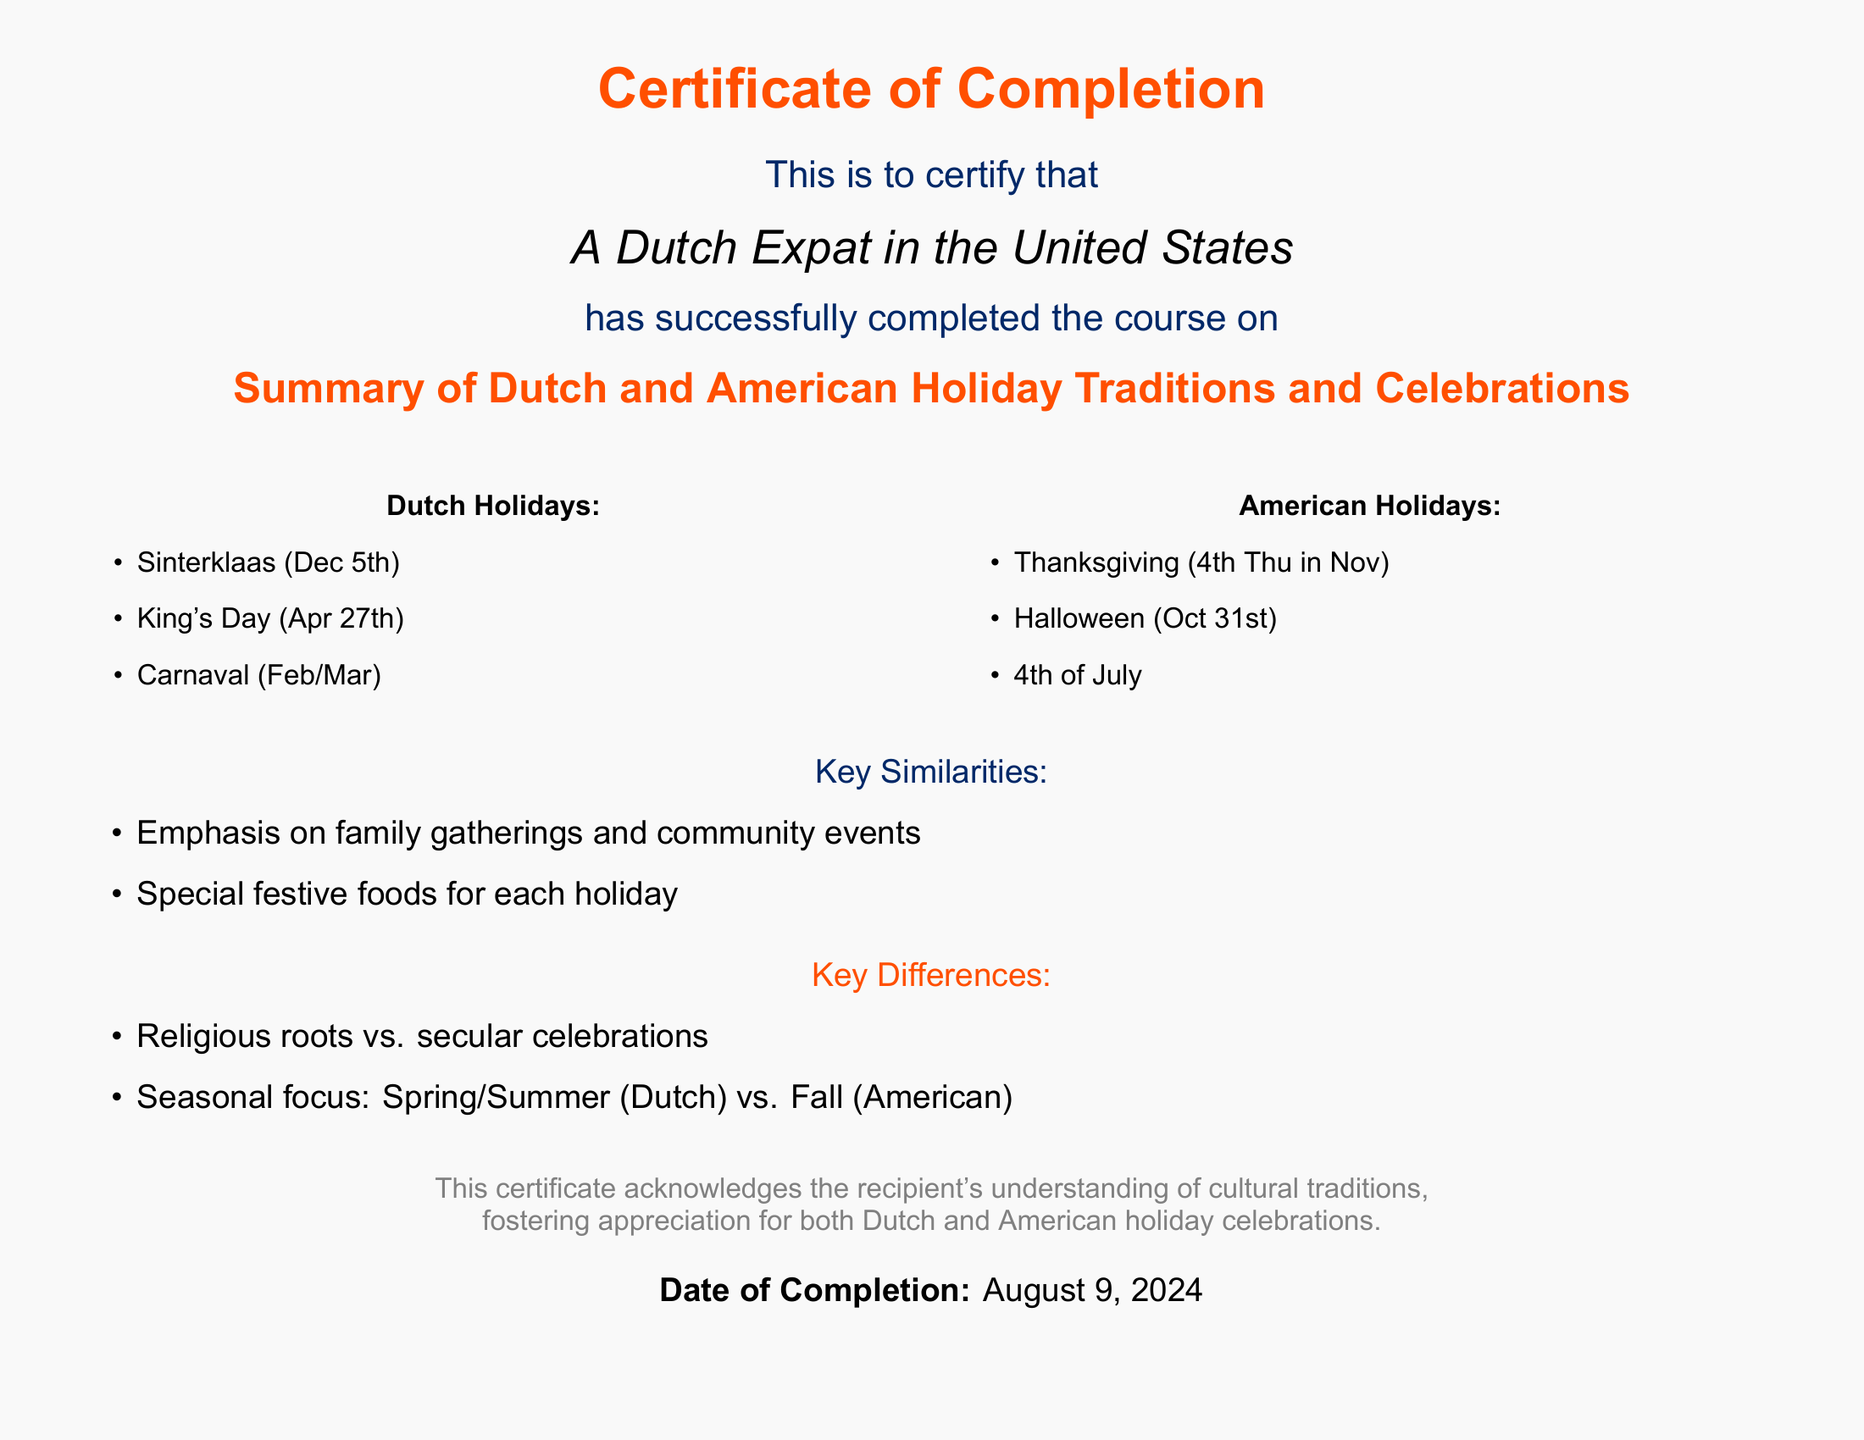what is the title of the course? The title of the course is presented prominently in the document and reflects the subject matter of the diploma, which is the cultural traditions being discussed.
Answer: Summary of Dutch and American Holiday Traditions and Celebrations how many Dutch holidays are listed? The document enumerates a specific number of Dutch holidays, which are outlined in a bulleted format.
Answer: 3 what date is King's Day celebrated? King's Day is clearly stated in the document, with the specific date provided for clarity.
Answer: Apr 27th what color is used for the American holidays section? The document specifies different colors for the Dutch and American sections, allowing for easy visual distinction between the two.
Answer: Usablue what is one key similarity mentioned about the holidays? The key similarities are explicitly outlined in the document, providing insights on how both cultures celebrate holidays.
Answer: Family gatherings what is the main seasonal focus for Dutch holidays? The seasonal focus for Dutch holidays is indicated in the differences section, contrasting it with American traditions.
Answer: Spring/Summer how many American holidays are listed? The number of American holidays is stated in the section dedicated to American celebrations in a clear format.
Answer: 3 what is the color theme for the document? The document uses a color code that reflects the cultural aspects, specifically for the sections and headings.
Answer: Dutch orange and Usablue what does this certificate acknowledge? The document provides a summary statement regarding the purpose of the certificate, clarifying its significance.
Answer: Understanding of cultural traditions 